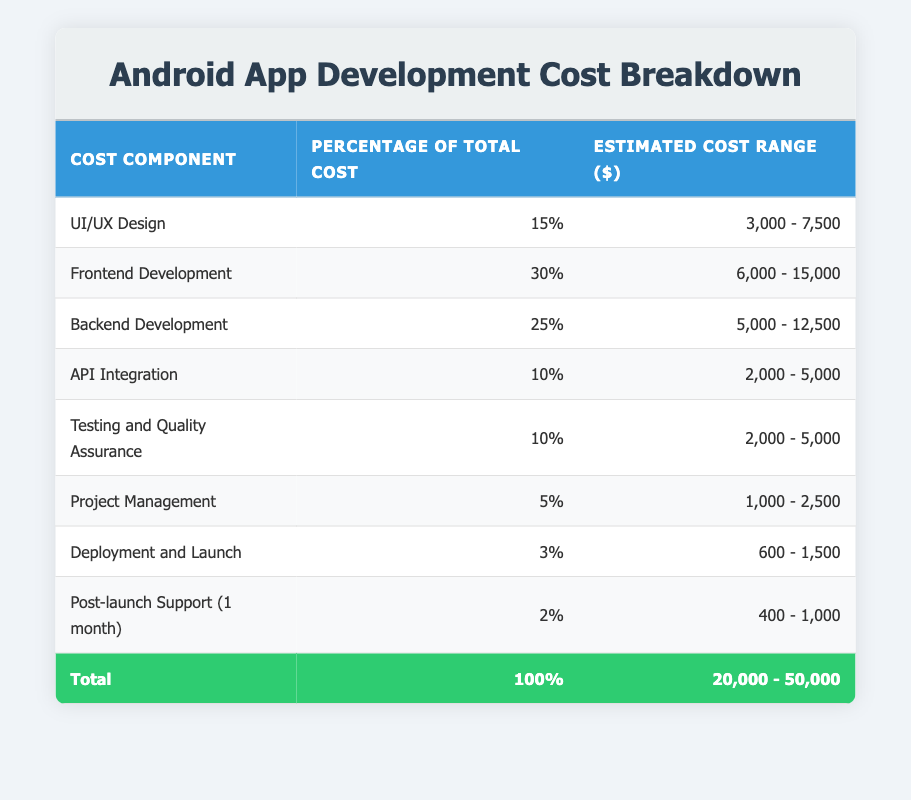What is the estimated cost range for UI/UX Design? From the table, the estimated cost range for UI/UX Design is explicitly listed in the third column corresponding to the first row. It states "3,000 - 7,500."
Answer: 3,000 - 7,500 What percentage of the total cost is attributed to Backend Development? By looking at the table, the percentage of total cost for Backend Development is found in the second column of the row corresponding to Backend Development, which indicates "25%."
Answer: 25% Is the cost for Deployment and Launch higher than that for Post-launch Support? Examination of the table shows that Deployment and Launch has an estimated cost range of "600 - 1,500" while Post-launch Support has "400 - 1,000." The maximum of Deployment and Launch (1,500) is indeed greater than the maximum of Post-launch Support (1,000), confirming the statement to be true.
Answer: Yes What is the total percentage of costs accounted for by API Integration and Testing and Quality Assurance combined? The percentages for API Integration and Testing and Quality Assurance are found as 10% for each. Adding them together gives us: 10% + 10% = 20%. Hence, the total percentage is 20%.
Answer: 20% If the total estimated cost range for the app development is 20,000 - 50,000, what is the average estimated cost from this range? To find the average total cost, we take the sum of the minimum and maximum values of the range: 20,000 + 50,000 = 70,000, and then divide by 2, which results in 70,000 / 2 = 35,000. Therefore, the average estimated cost is 35,000.
Answer: 35,000 How much does Project Management account for in terms of cost if the total estimated cost is set at the mid-point of the range 20,000 - 50,000? First, we calculate the midpoint of the total cost range: (20,000 + 50,000) / 2 = 35,000. Since Project Management is 5% of the total cost, we calculate 5% of 35,000 as: 0.05 * 35,000 = 1,750. Hence, Project Management accounts for 1,750.
Answer: 1,750 Is the cost for Frontend Development more than that for UI/UX Design? From the table, the estimated cost range for Frontend Development is "6,000 - 15,000" and for UI/UX Design is "3,000 - 7,500." Since the minimum of Frontend Development (6,000) is greater than the maximum of UI/UX Design (7,500), the statement is true.
Answer: Yes If combined, what is the approximate cost range for Testing and Quality Assurance and API Integration? Testing and Quality Assurance has a cost range of "2,000 - 5,000" and API Integration has a range of "2,000 - 5,000." By adding the ranges, we get a combined minimum of 2,000 + 2,000 = 4,000 and a combined maximum of 5,000 + 5,000 = 10,000. Therefore, the approximate cost range combined is "4,000 - 10,000."
Answer: 4,000 - 10,000 What is the least percentage of total cost from the table, and to which component does it correspond? Observing the percentages in the table, the least percentage is 2% which corresponds to the Post-launch Support (1 month) component as seen in the second column of the last row.
Answer: 2%, Post-launch Support (1 month) 